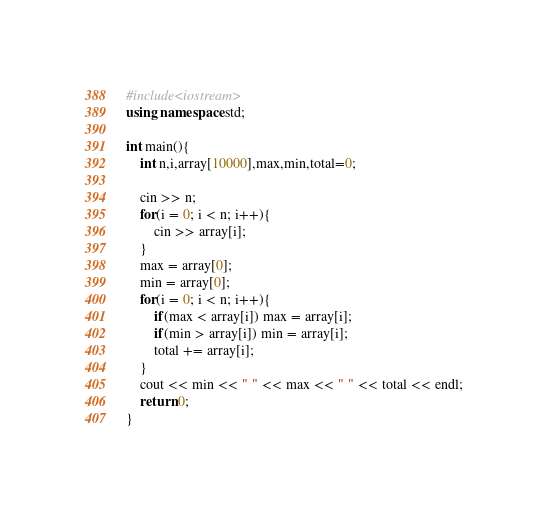<code> <loc_0><loc_0><loc_500><loc_500><_C++_>#include<iostream>
using namespace std;

int main(){
    int n,i,array[10000],max,min,total=0;
    
    cin >> n;
    for(i = 0; i < n; i++){
        cin >> array[i];
    }
    max = array[0];
    min = array[0];
    for(i = 0; i < n; i++){
        if(max < array[i]) max = array[i];
        if(min > array[i]) min = array[i];
        total += array[i];
    }
    cout << min << " " << max << " " << total << endl;
    return 0;
}
</code> 